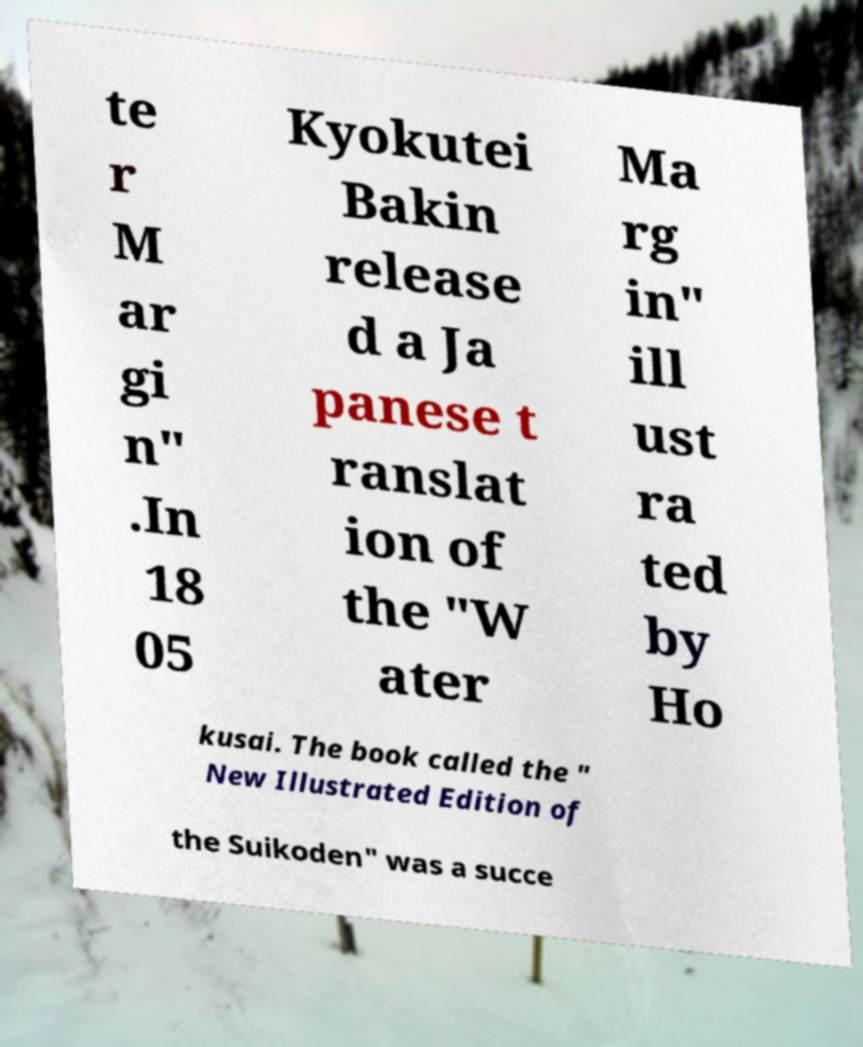Please identify and transcribe the text found in this image. te r M ar gi n" .In 18 05 Kyokutei Bakin release d a Ja panese t ranslat ion of the "W ater Ma rg in" ill ust ra ted by Ho kusai. The book called the " New Illustrated Edition of the Suikoden" was a succe 